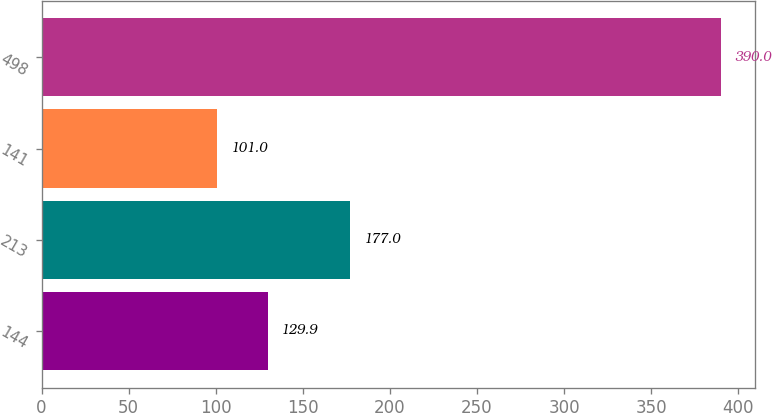<chart> <loc_0><loc_0><loc_500><loc_500><bar_chart><fcel>144<fcel>213<fcel>141<fcel>498<nl><fcel>129.9<fcel>177<fcel>101<fcel>390<nl></chart> 